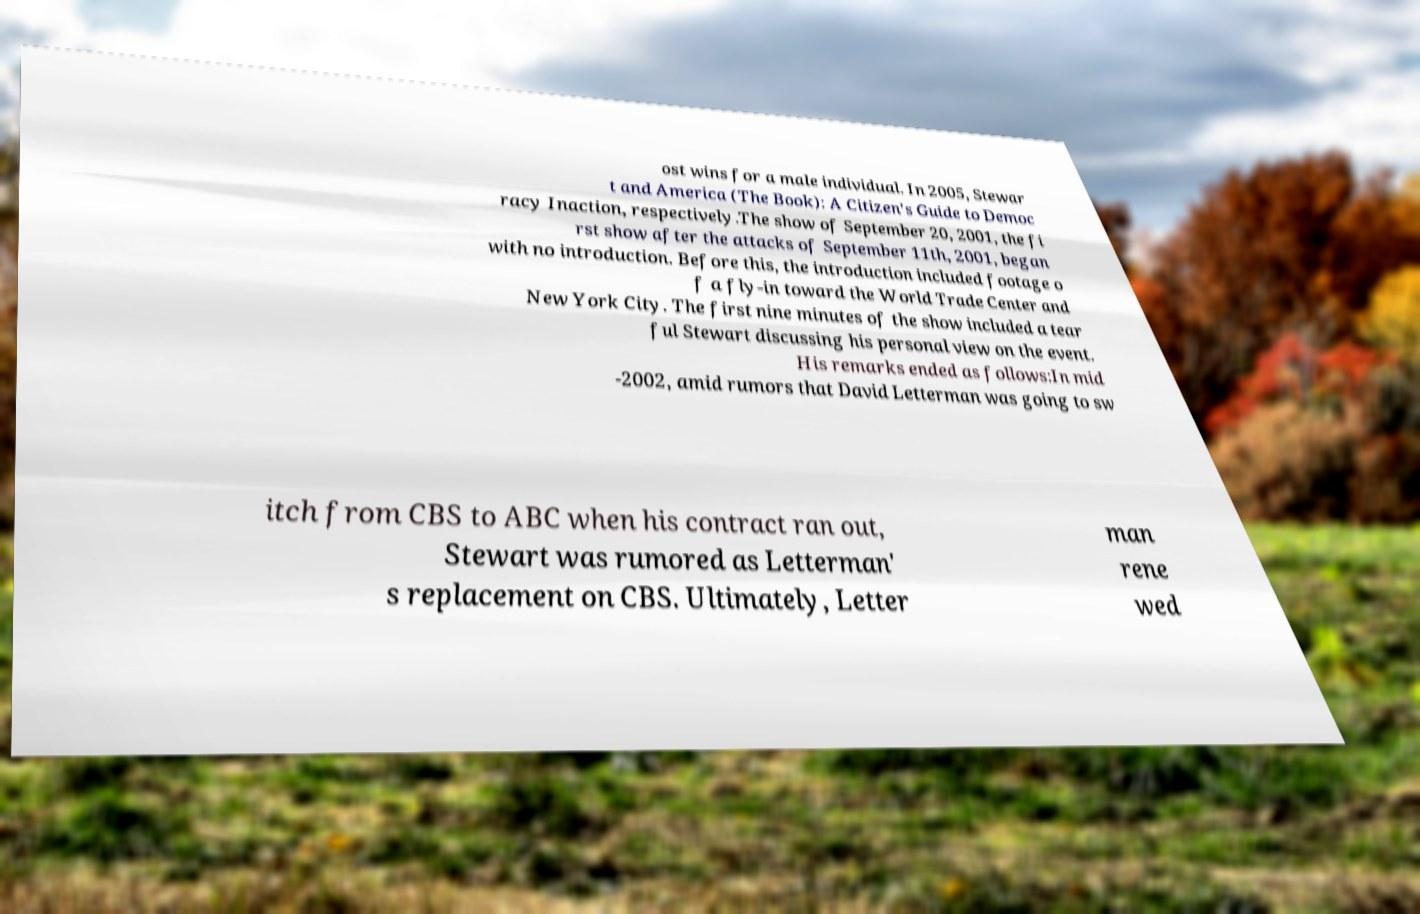Please identify and transcribe the text found in this image. ost wins for a male individual. In 2005, Stewar t and America (The Book): A Citizen's Guide to Democ racy Inaction, respectively.The show of September 20, 2001, the fi rst show after the attacks of September 11th, 2001, began with no introduction. Before this, the introduction included footage o f a fly-in toward the World Trade Center and New York City. The first nine minutes of the show included a tear ful Stewart discussing his personal view on the event. His remarks ended as follows:In mid -2002, amid rumors that David Letterman was going to sw itch from CBS to ABC when his contract ran out, Stewart was rumored as Letterman' s replacement on CBS. Ultimately, Letter man rene wed 